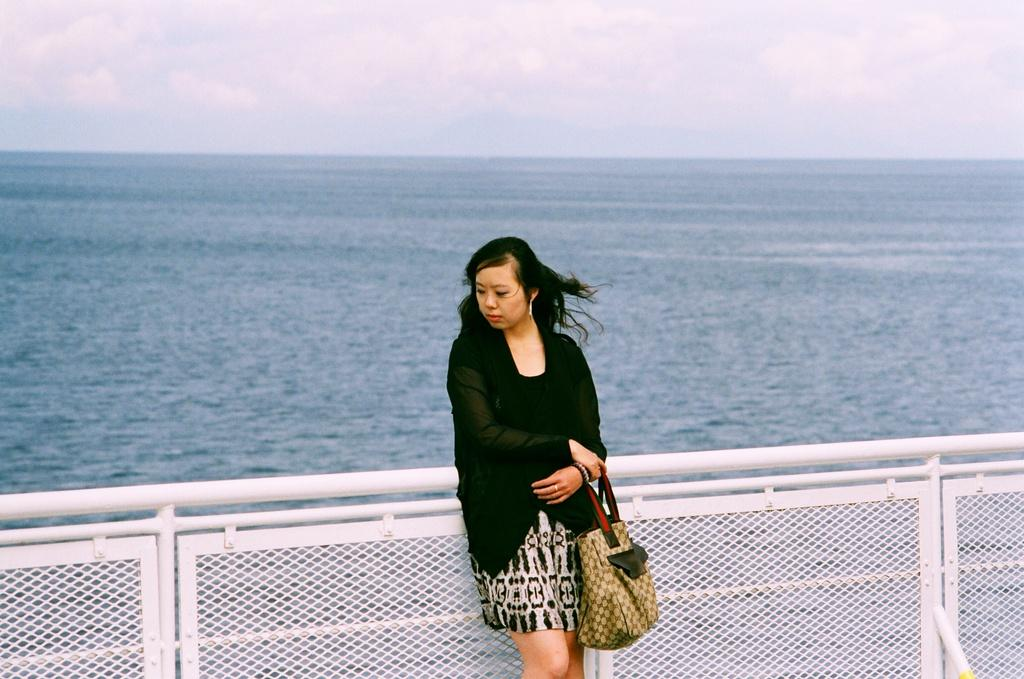Who is present in the image? There is a woman in the image. What is the woman holding in the image? The woman is holding a bag. Where is the woman standing in the image? The woman is standing beside a fence. What can be seen in the background of the image? There is a large water body visible in the background. How would you describe the weather based on the image? The sky is cloudy in the image. What type of plantation can be seen in the image? There is no plantation visible in the image. Can you tell me how many wounds the woman has in the image? There is no indication of any wounds on the woman in the image. 